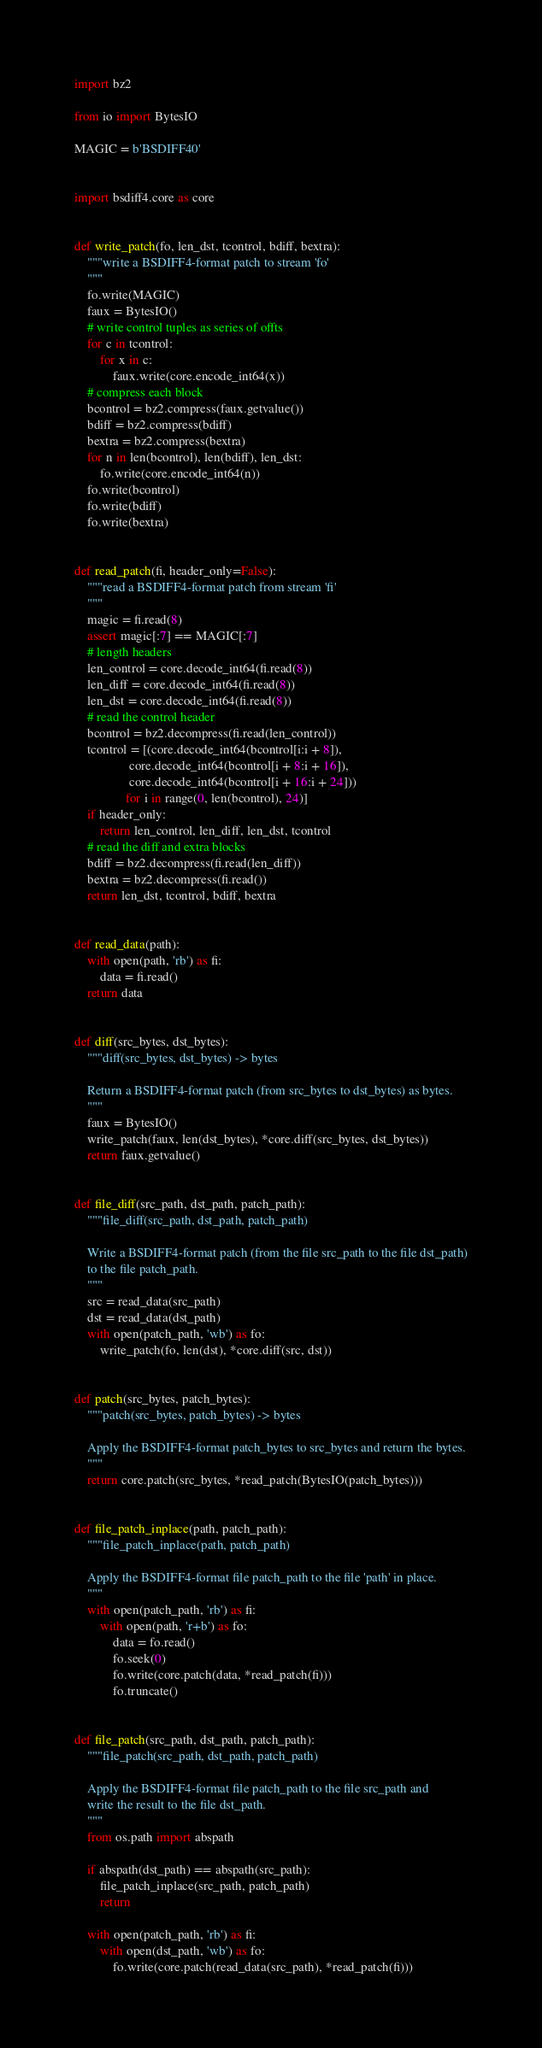<code> <loc_0><loc_0><loc_500><loc_500><_Python_>import bz2

from io import BytesIO

MAGIC = b'BSDIFF40'


import bsdiff4.core as core


def write_patch(fo, len_dst, tcontrol, bdiff, bextra):
    """write a BSDIFF4-format patch to stream 'fo'
    """
    fo.write(MAGIC)
    faux = BytesIO()
    # write control tuples as series of offts
    for c in tcontrol:
        for x in c:
            faux.write(core.encode_int64(x))
    # compress each block
    bcontrol = bz2.compress(faux.getvalue())
    bdiff = bz2.compress(bdiff)
    bextra = bz2.compress(bextra)
    for n in len(bcontrol), len(bdiff), len_dst:
        fo.write(core.encode_int64(n))
    fo.write(bcontrol)
    fo.write(bdiff)
    fo.write(bextra)


def read_patch(fi, header_only=False):
    """read a BSDIFF4-format patch from stream 'fi'
    """
    magic = fi.read(8)
    assert magic[:7] == MAGIC[:7]
    # length headers
    len_control = core.decode_int64(fi.read(8))
    len_diff = core.decode_int64(fi.read(8))
    len_dst = core.decode_int64(fi.read(8))
    # read the control header
    bcontrol = bz2.decompress(fi.read(len_control))
    tcontrol = [(core.decode_int64(bcontrol[i:i + 8]),
                 core.decode_int64(bcontrol[i + 8:i + 16]),
                 core.decode_int64(bcontrol[i + 16:i + 24]))
                for i in range(0, len(bcontrol), 24)]
    if header_only:
        return len_control, len_diff, len_dst, tcontrol
    # read the diff and extra blocks
    bdiff = bz2.decompress(fi.read(len_diff))
    bextra = bz2.decompress(fi.read())
    return len_dst, tcontrol, bdiff, bextra


def read_data(path):
    with open(path, 'rb') as fi:
        data = fi.read()
    return data


def diff(src_bytes, dst_bytes):
    """diff(src_bytes, dst_bytes) -> bytes

    Return a BSDIFF4-format patch (from src_bytes to dst_bytes) as bytes.
    """
    faux = BytesIO()
    write_patch(faux, len(dst_bytes), *core.diff(src_bytes, dst_bytes))
    return faux.getvalue()


def file_diff(src_path, dst_path, patch_path):
    """file_diff(src_path, dst_path, patch_path)

    Write a BSDIFF4-format patch (from the file src_path to the file dst_path)
    to the file patch_path.
    """
    src = read_data(src_path)
    dst = read_data(dst_path)
    with open(patch_path, 'wb') as fo:
        write_patch(fo, len(dst), *core.diff(src, dst))


def patch(src_bytes, patch_bytes):
    """patch(src_bytes, patch_bytes) -> bytes

    Apply the BSDIFF4-format patch_bytes to src_bytes and return the bytes.
    """
    return core.patch(src_bytes, *read_patch(BytesIO(patch_bytes)))


def file_patch_inplace(path, patch_path):
    """file_patch_inplace(path, patch_path)

    Apply the BSDIFF4-format file patch_path to the file 'path' in place.
    """
    with open(patch_path, 'rb') as fi:
        with open(path, 'r+b') as fo:
            data = fo.read()
            fo.seek(0)
            fo.write(core.patch(data, *read_patch(fi)))
            fo.truncate()


def file_patch(src_path, dst_path, patch_path):
    """file_patch(src_path, dst_path, patch_path)

    Apply the BSDIFF4-format file patch_path to the file src_path and
    write the result to the file dst_path.
    """
    from os.path import abspath

    if abspath(dst_path) == abspath(src_path):
        file_patch_inplace(src_path, patch_path)
        return

    with open(patch_path, 'rb') as fi:
        with open(dst_path, 'wb') as fo:
            fo.write(core.patch(read_data(src_path), *read_patch(fi)))
</code> 